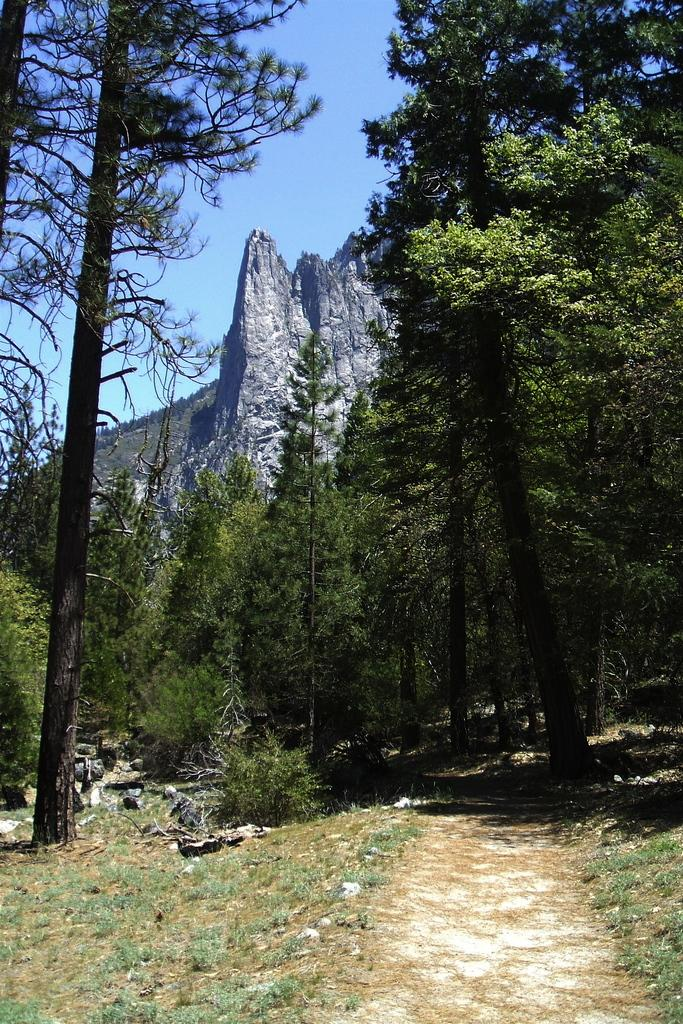What is the main feature of the image? There is a road in the image. What can be seen on the sides of the road? There are trees on the sides of the road. What type of vegetation is present on the ground? There is grass on the ground. What can be seen in the distance in the image? There are hills visible in the background. What is visible above the hills in the image? The sky is visible in the background. How much profit can be made from the trees in the image? There is no information about profit in the image, as it focuses on the visual elements of the scene. 